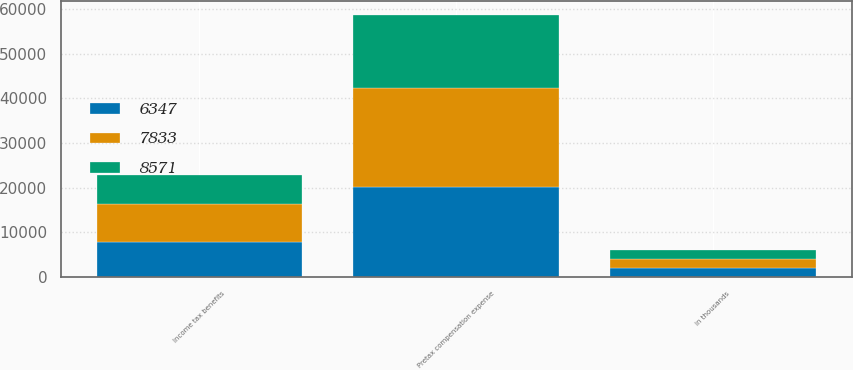Convert chart to OTSL. <chart><loc_0><loc_0><loc_500><loc_500><stacked_bar_chart><ecel><fcel>in thousands<fcel>Pretax compensation expense<fcel>Income tax benefits<nl><fcel>8571<fcel>2015<fcel>16362<fcel>6347<nl><fcel>7833<fcel>2014<fcel>22217<fcel>8571<nl><fcel>6347<fcel>2013<fcel>20187<fcel>7833<nl></chart> 